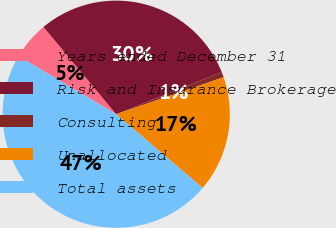Convert chart to OTSL. <chart><loc_0><loc_0><loc_500><loc_500><pie_chart><fcel>Years ended December 31<fcel>Risk and Insurance Brokerage<fcel>Consulting<fcel>Unallocated<fcel>Total assets<nl><fcel>5.41%<fcel>30.01%<fcel>0.76%<fcel>16.52%<fcel>47.29%<nl></chart> 